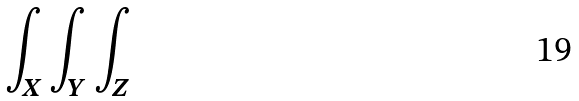<formula> <loc_0><loc_0><loc_500><loc_500>\int _ { X } \int _ { Y } \int _ { Z }</formula> 